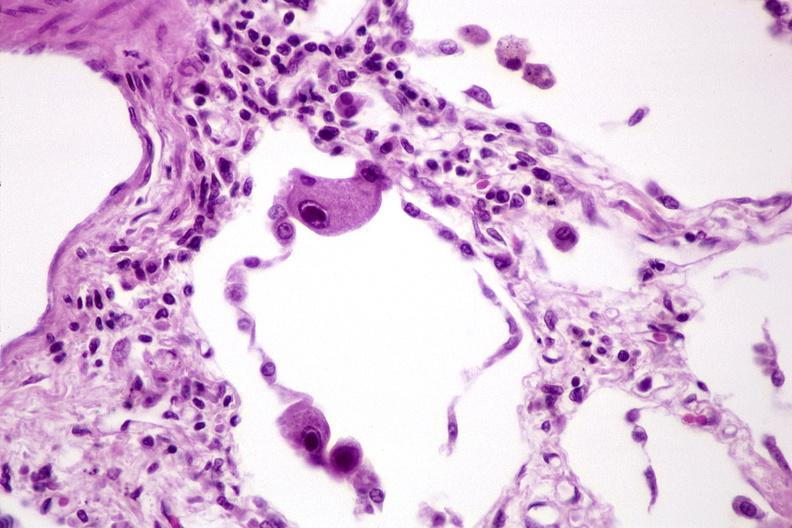s normal ovary present?
Answer the question using a single word or phrase. No 